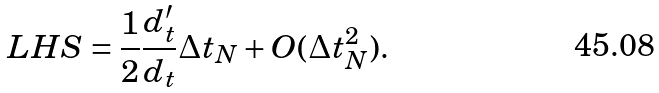Convert formula to latex. <formula><loc_0><loc_0><loc_500><loc_500>L H S = \frac { 1 } { 2 } \frac { d ^ { \prime } _ { t } } { d _ { t } } \Delta { t } _ { N } + O ( \Delta { t } _ { N } ^ { 2 } ) .</formula> 